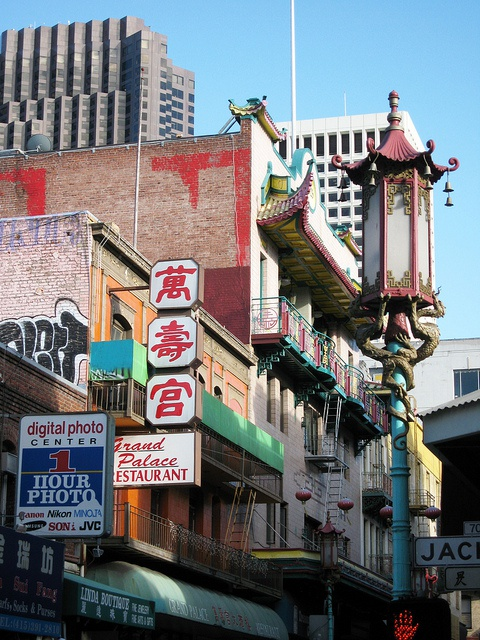Describe the objects in this image and their specific colors. I can see stop sign in lightblue, black, maroon, brown, and red tones and traffic light in lightblue, black, maroon, brown, and red tones in this image. 